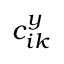<formula> <loc_0><loc_0><loc_500><loc_500>c _ { i k } ^ { y }</formula> 